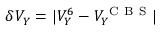<formula> <loc_0><loc_0><loc_500><loc_500>\delta V _ { Y } = | V _ { Y } ^ { 6 } - V _ { Y } ^ { C B S } |</formula> 